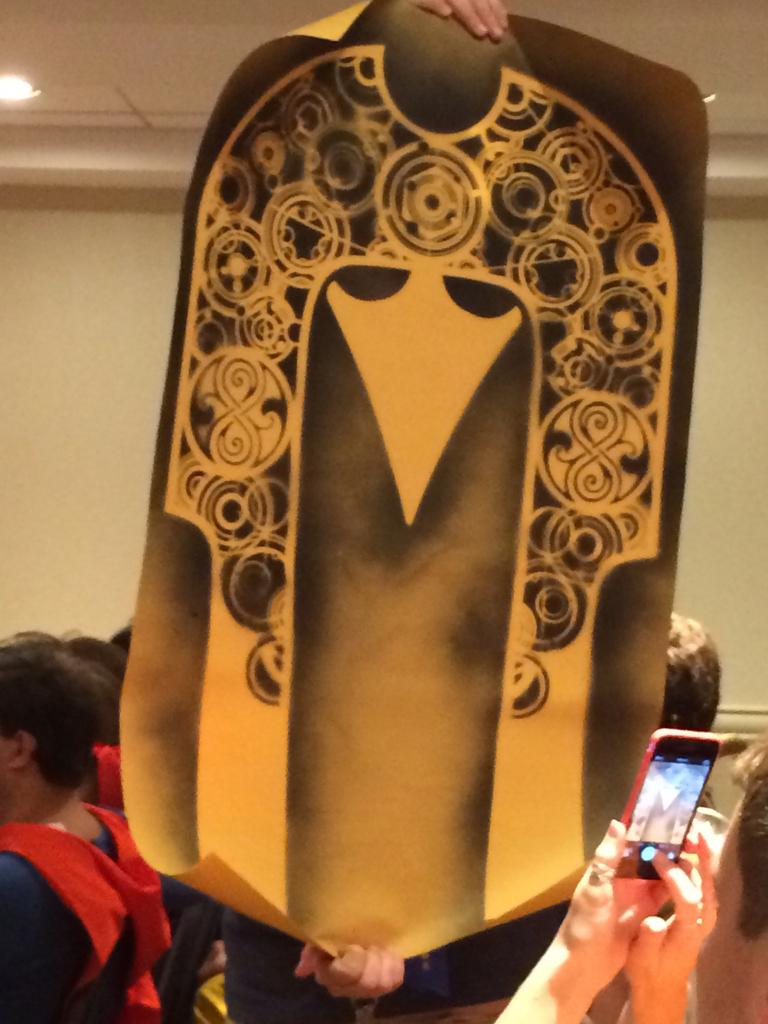How many people are in the image? There are people in the image, but the exact number is not specified. What is one person doing in the image? One person is holding a poster in the image. What can be seen in the background of the image? There is a wall and light visible in the background of the image. How many dogs are visible in the image? There are no dogs present in the image. What type of joke is being told by the person holding the poster? There is no indication of a joke being told in the image; the person is simply holding a poster. 